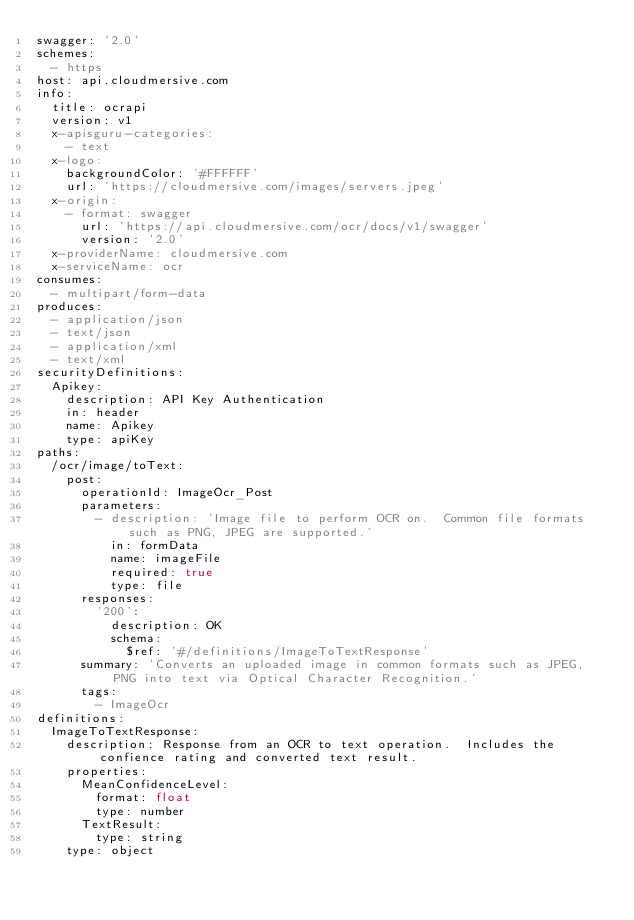Convert code to text. <code><loc_0><loc_0><loc_500><loc_500><_YAML_>swagger: '2.0'
schemes:
  - https
host: api.cloudmersive.com
info:
  title: ocrapi
  version: v1
  x-apisguru-categories:
    - text
  x-logo:
    backgroundColor: '#FFFFFF'
    url: 'https://cloudmersive.com/images/servers.jpeg'
  x-origin:
    - format: swagger
      url: 'https://api.cloudmersive.com/ocr/docs/v1/swagger'
      version: '2.0'
  x-providerName: cloudmersive.com
  x-serviceName: ocr
consumes:
  - multipart/form-data
produces:
  - application/json
  - text/json
  - application/xml
  - text/xml
securityDefinitions:
  Apikey:
    description: API Key Authentication
    in: header
    name: Apikey
    type: apiKey
paths:
  /ocr/image/toText:
    post:
      operationId: ImageOcr_Post
      parameters:
        - description: 'Image file to perform OCR on.  Common file formats such as PNG, JPEG are supported.'
          in: formData
          name: imageFile
          required: true
          type: file
      responses:
        '200':
          description: OK
          schema:
            $ref: '#/definitions/ImageToTextResponse'
      summary: 'Converts an uploaded image in common formats such as JPEG, PNG into text via Optical Character Recognition.'
      tags:
        - ImageOcr
definitions:
  ImageToTextResponse:
    description: Response from an OCR to text operation.  Includes the confience rating and converted text result.
    properties:
      MeanConfidenceLevel:
        format: float
        type: number
      TextResult:
        type: string
    type: object
</code> 